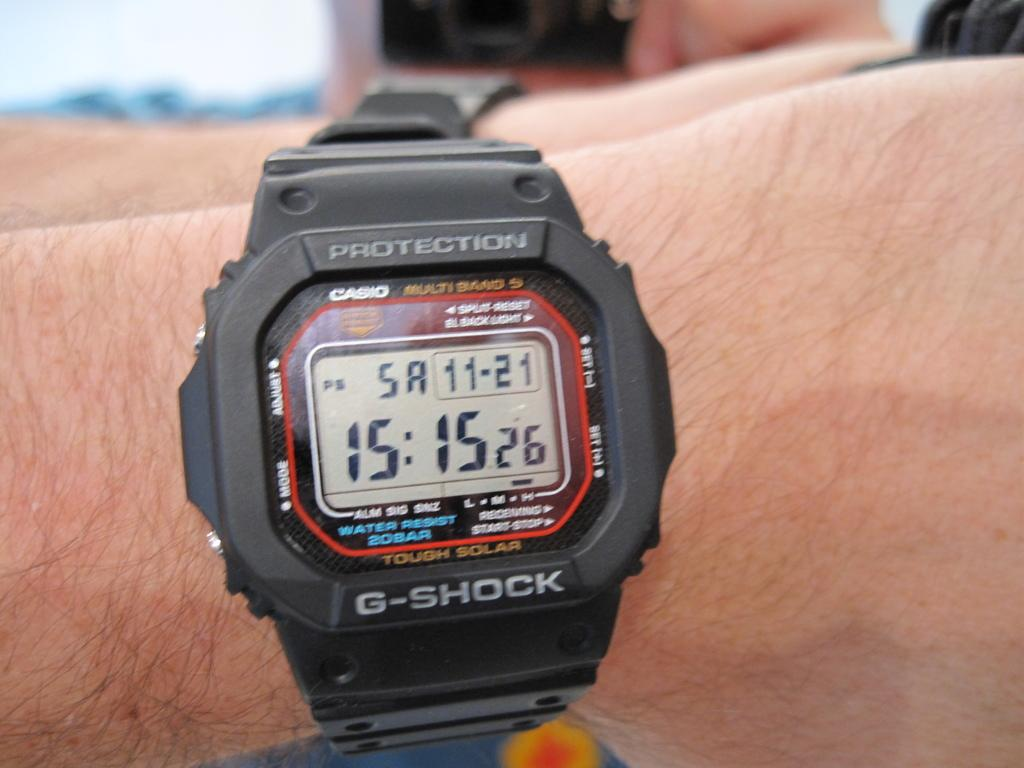<image>
Give a short and clear explanation of the subsequent image. A hand wearing a black protection g shock branded watch whose time reads 15:15. 